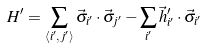Convert formula to latex. <formula><loc_0><loc_0><loc_500><loc_500>H ^ { \prime } = \sum _ { \langle i ^ { \prime } , j ^ { \prime } \rangle } \vec { \sigma } _ { i ^ { \prime } } \cdot \vec { \sigma } _ { j ^ { \prime } } - \sum _ { i ^ { \prime } } \vec { h } ^ { \prime } _ { i ^ { \prime } } \cdot \vec { \sigma } _ { i ^ { \prime } }</formula> 